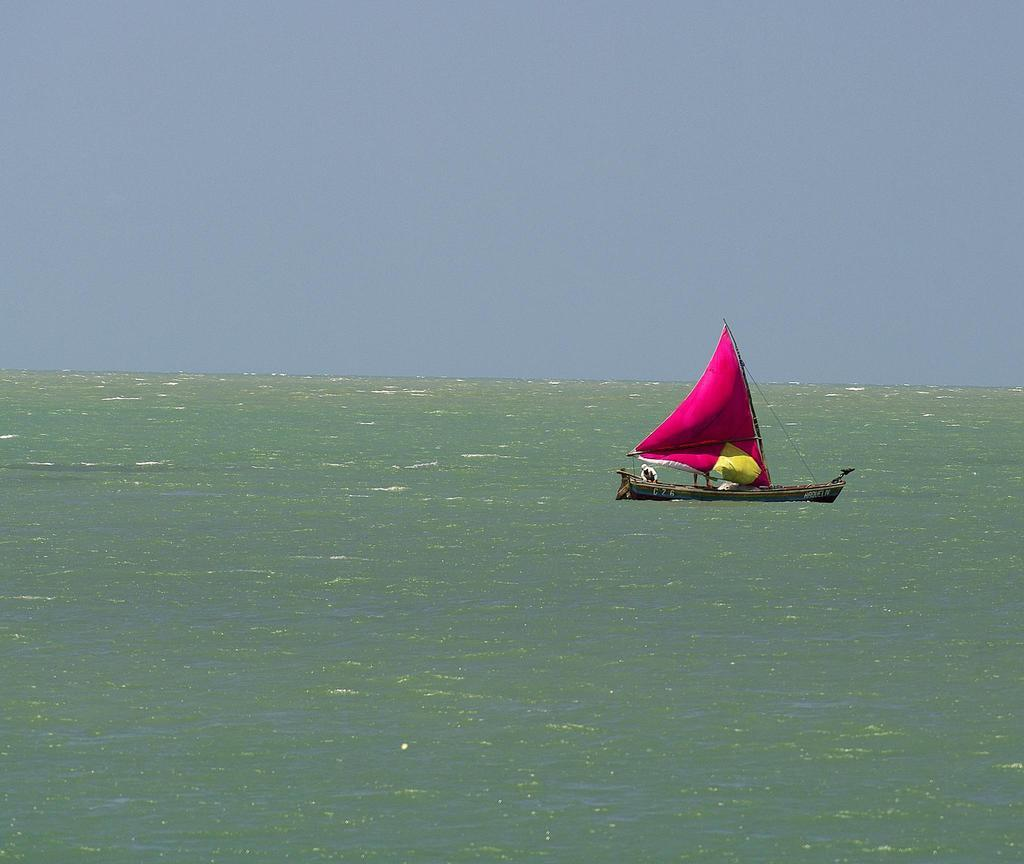What is the main subject of the image? There is a person on a boat in the image. What type of environment is depicted in the image? The image shows soil, water, and the sky, suggesting a natural setting. Can you describe the water in the image? There is water visible in the image. What is visible in the background of the image? The sky is visible in the background of the image. How many circles can be seen in the image? There are no circles present in the image. What type of fowl is swimming in the water in the image? There is no fowl present in the image; it only shows a person on a boat. 